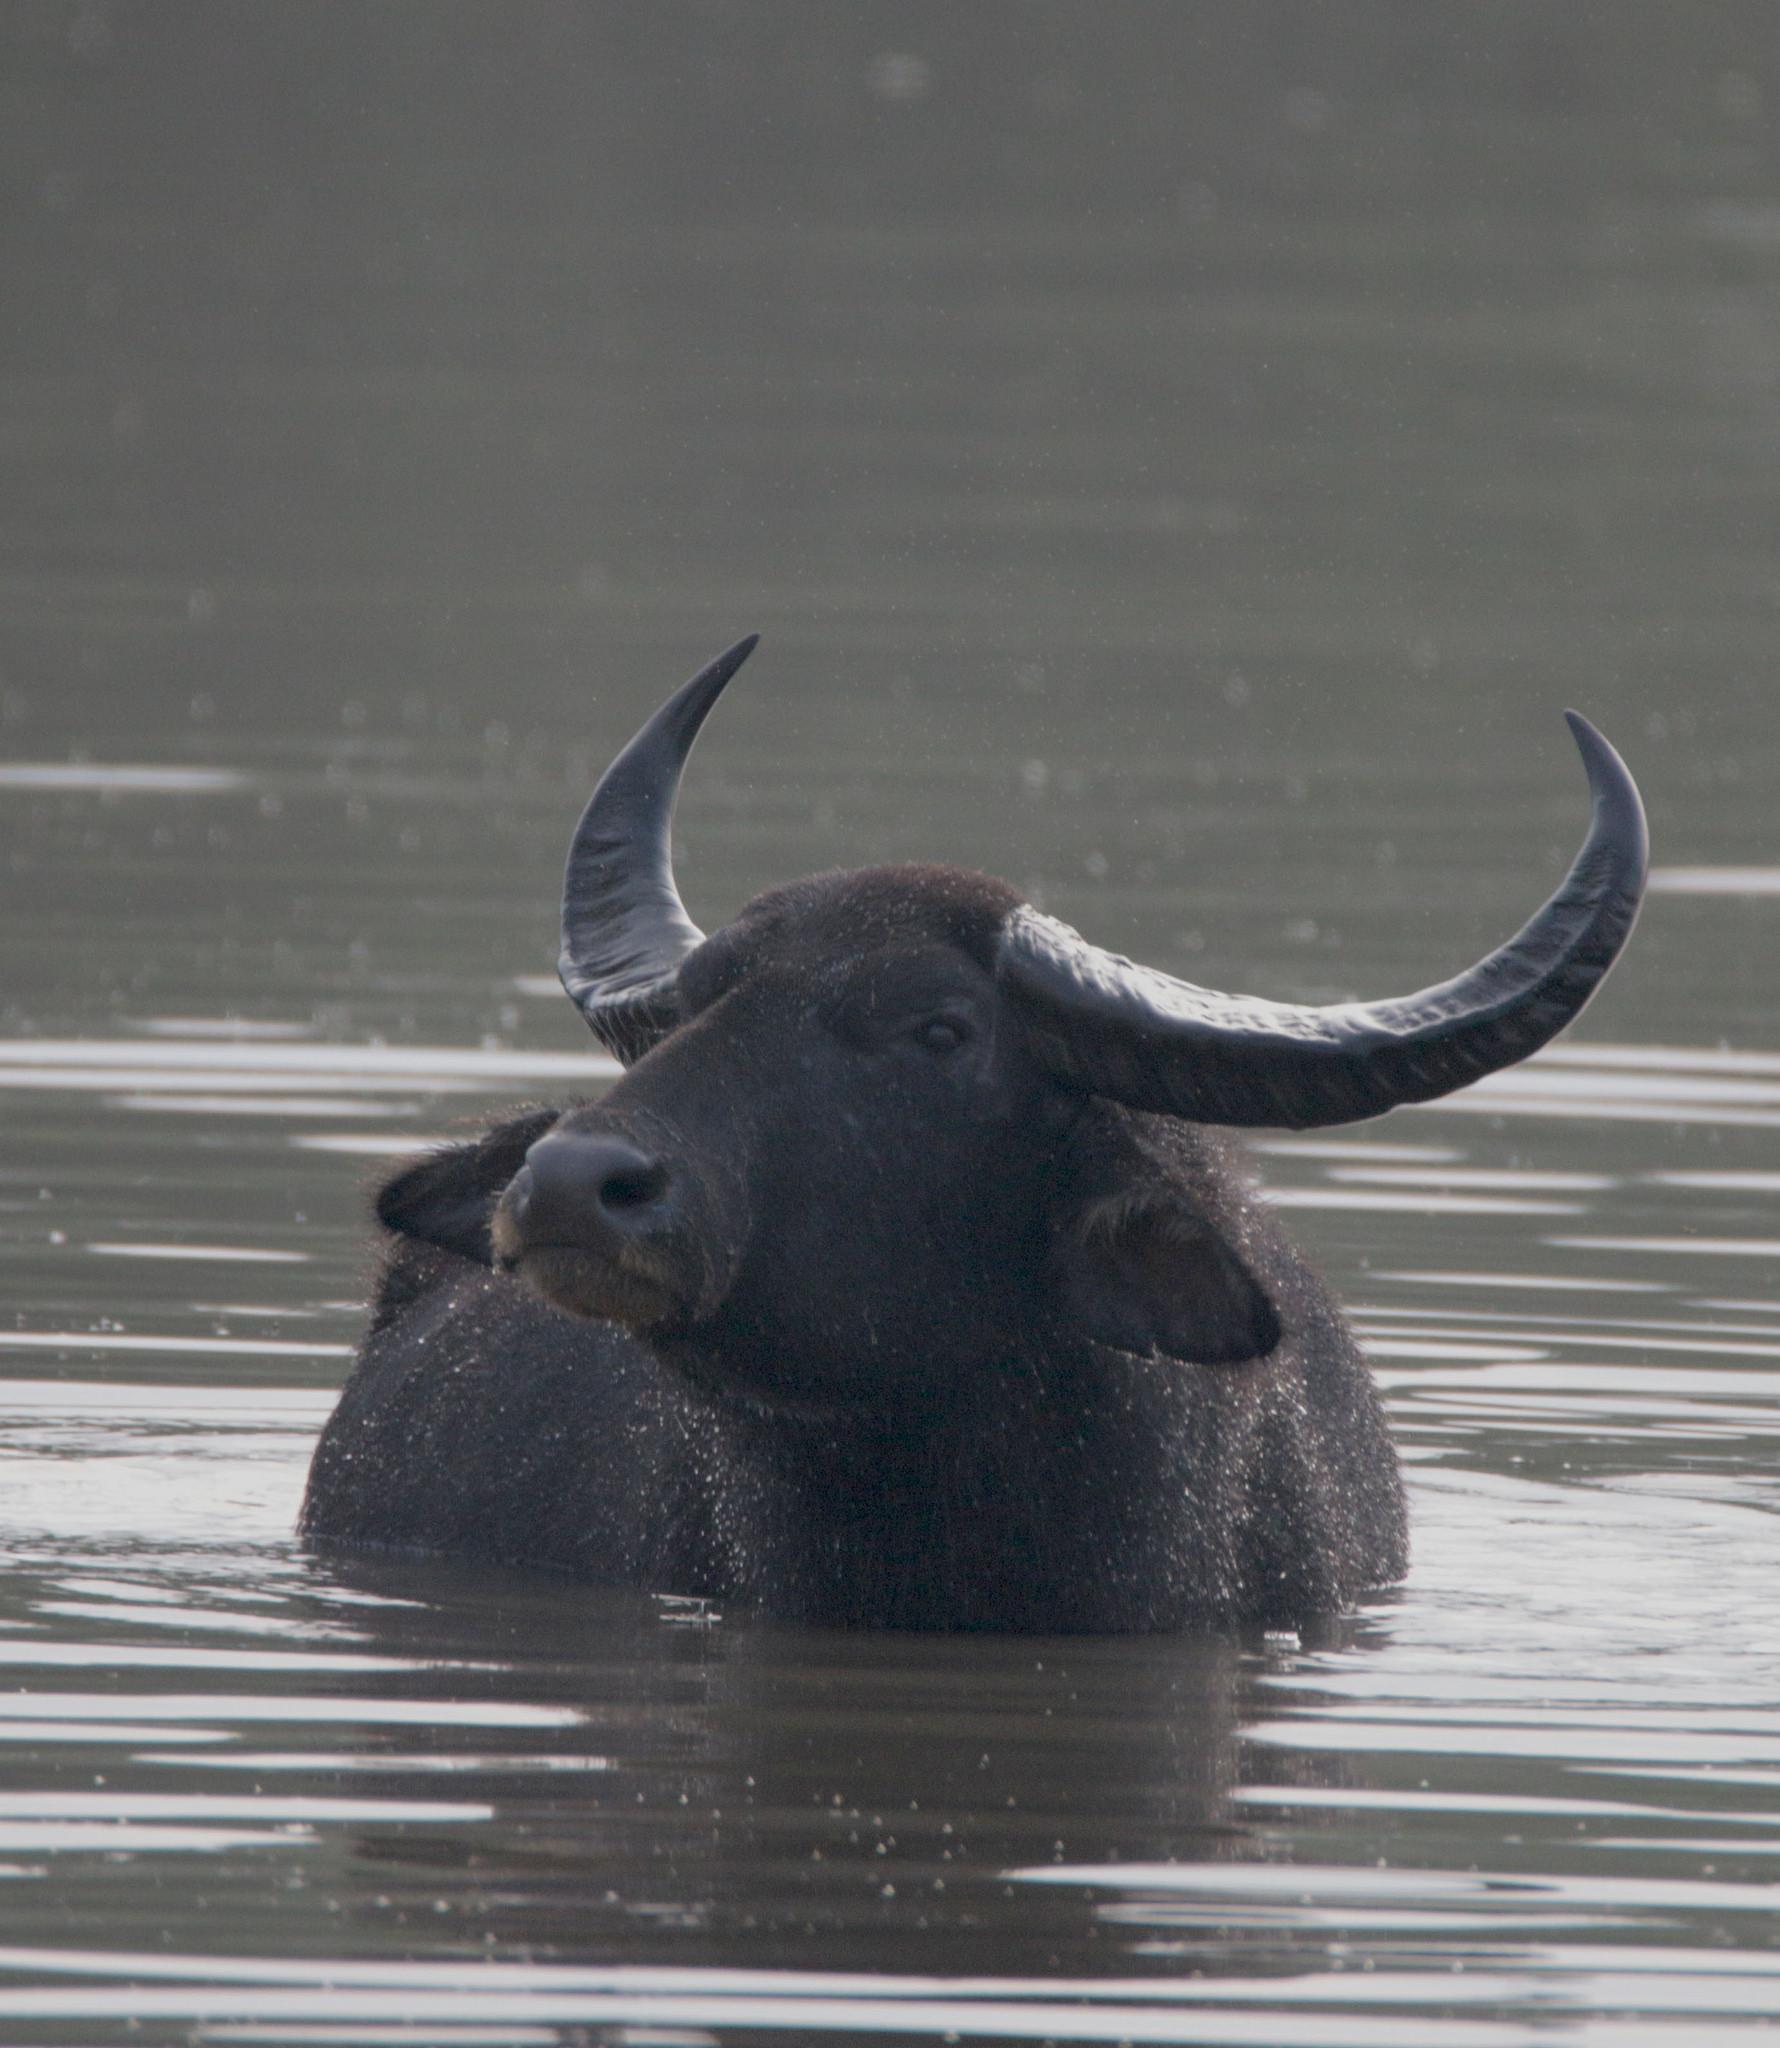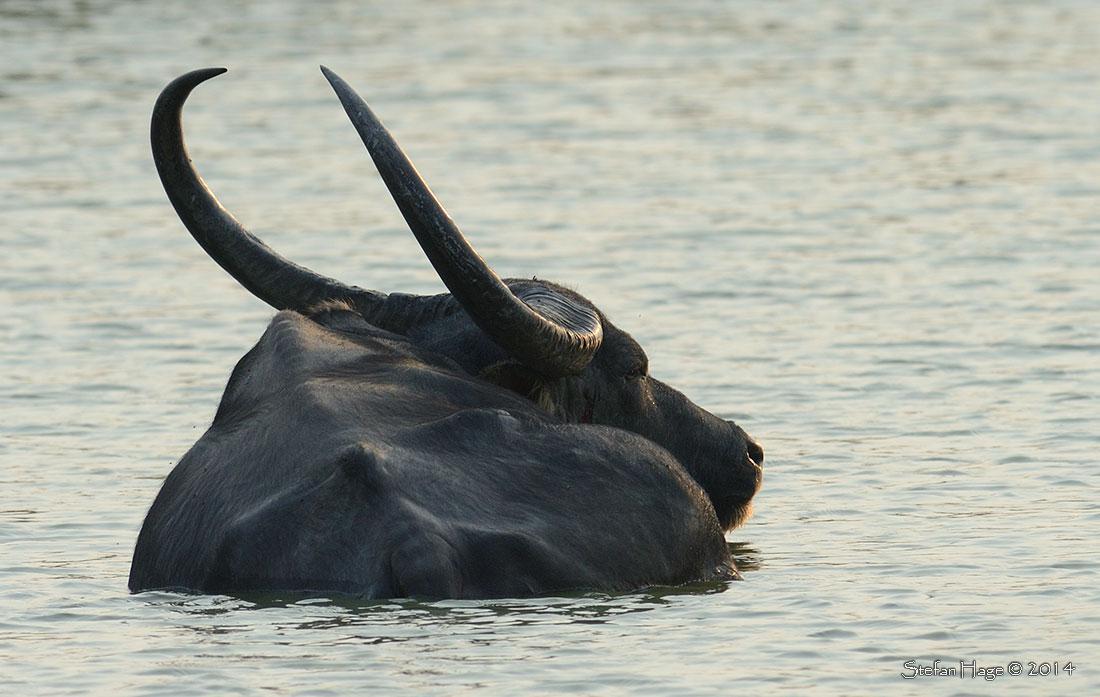The first image is the image on the left, the second image is the image on the right. Examine the images to the left and right. Is the description "There is more than one animal species." accurate? Answer yes or no. No. The first image is the image on the left, the second image is the image on the right. Evaluate the accuracy of this statement regarding the images: "There are two water buffallos wading in water.". Is it true? Answer yes or no. Yes. 